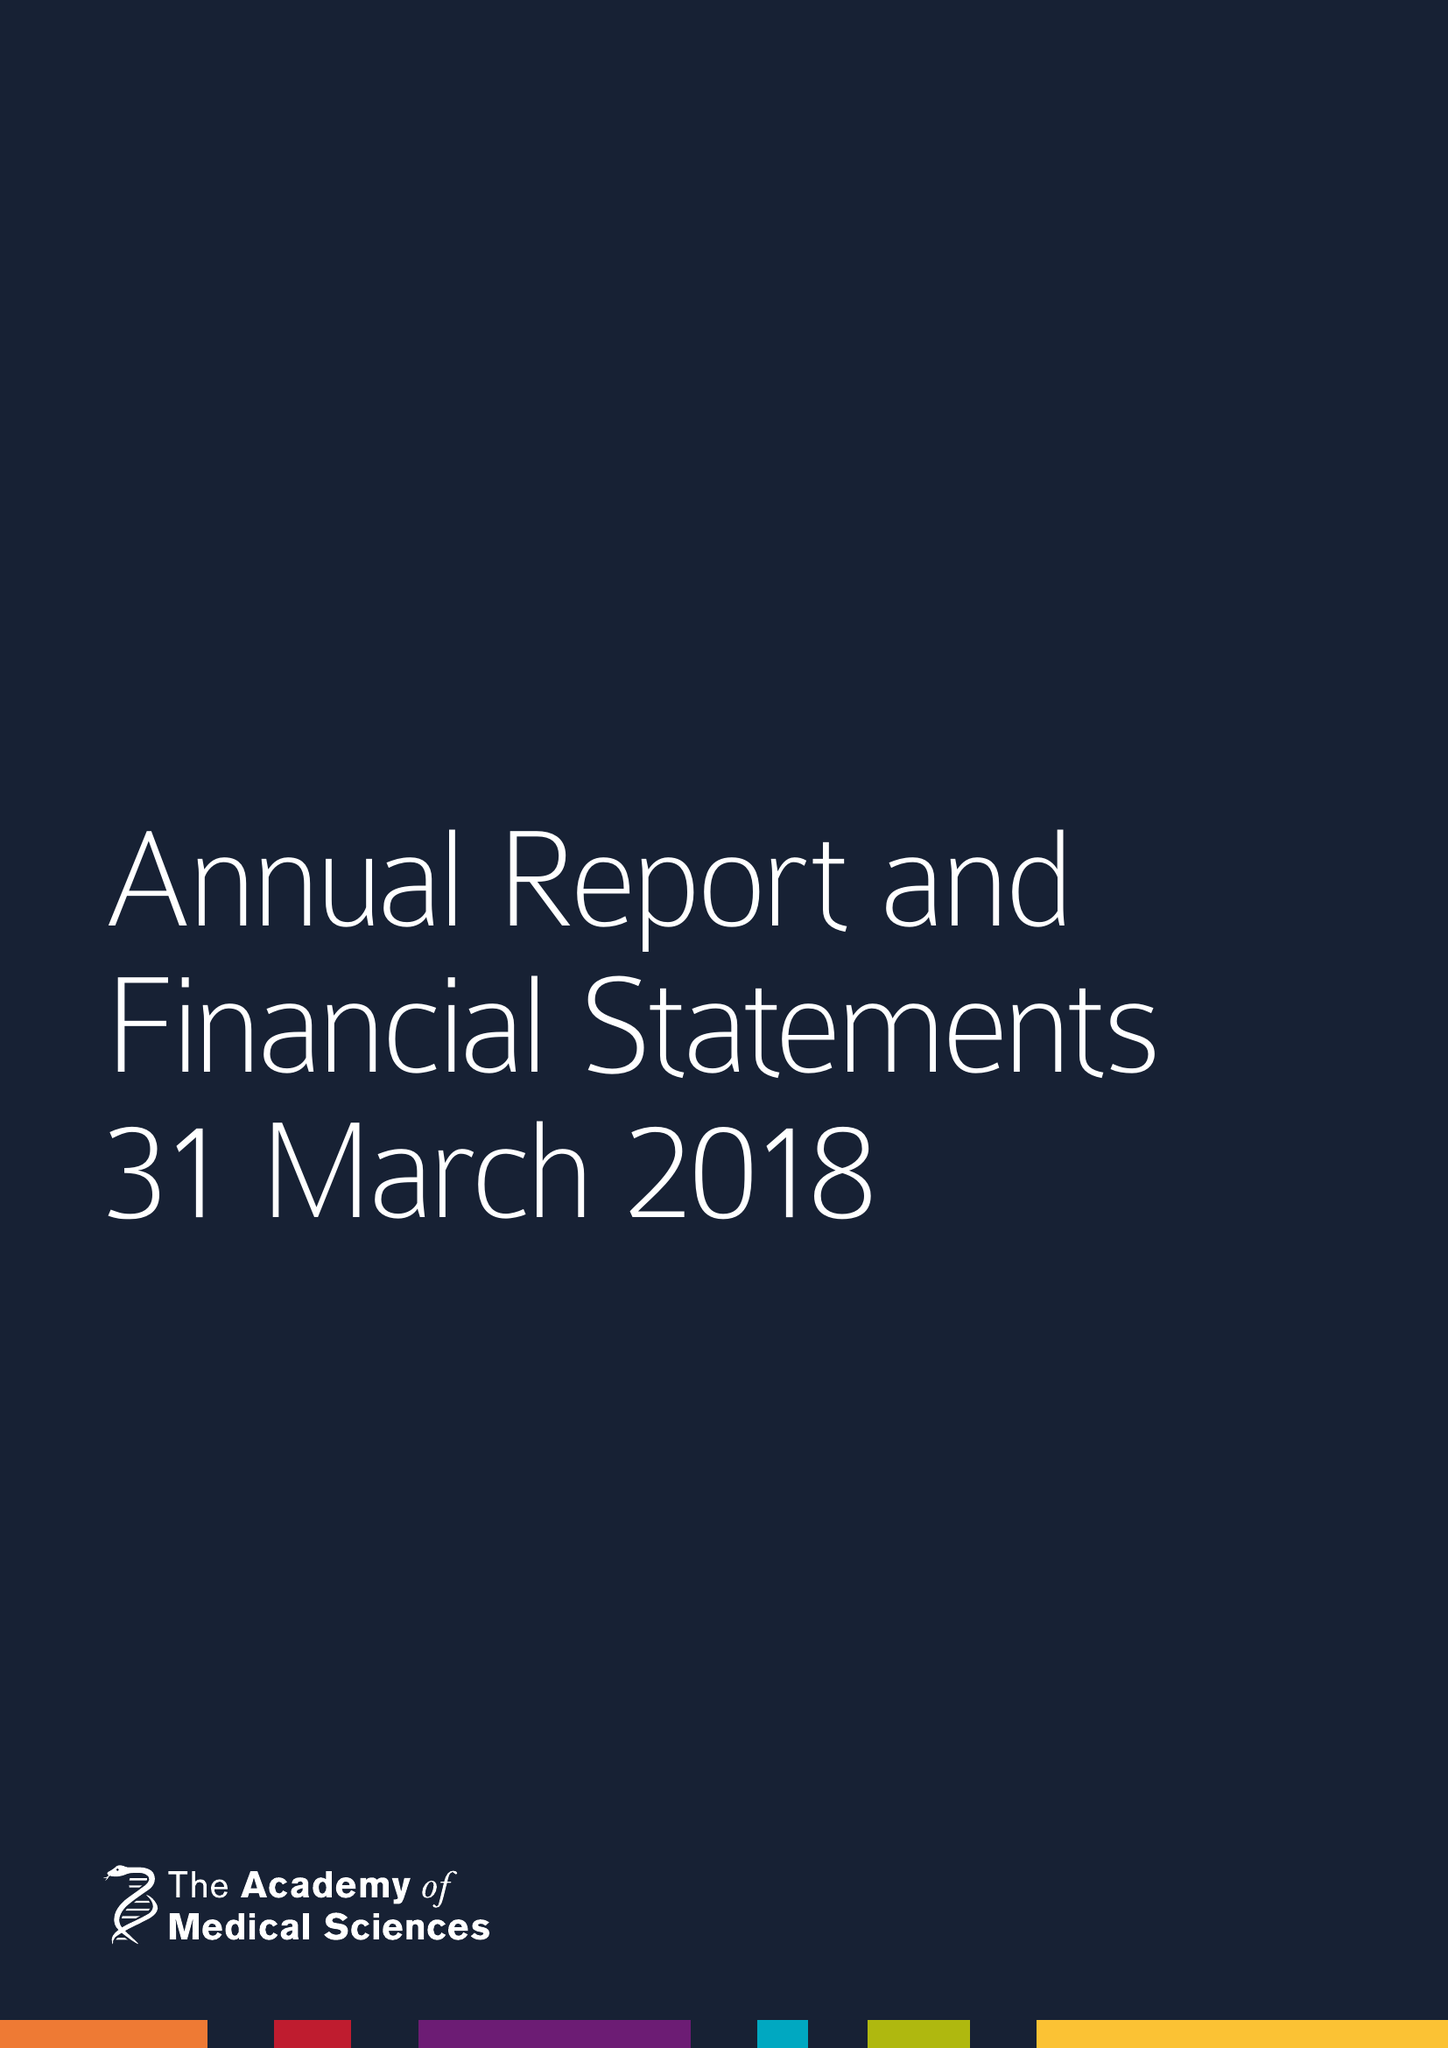What is the value for the report_date?
Answer the question using a single word or phrase. 2018-03-31 